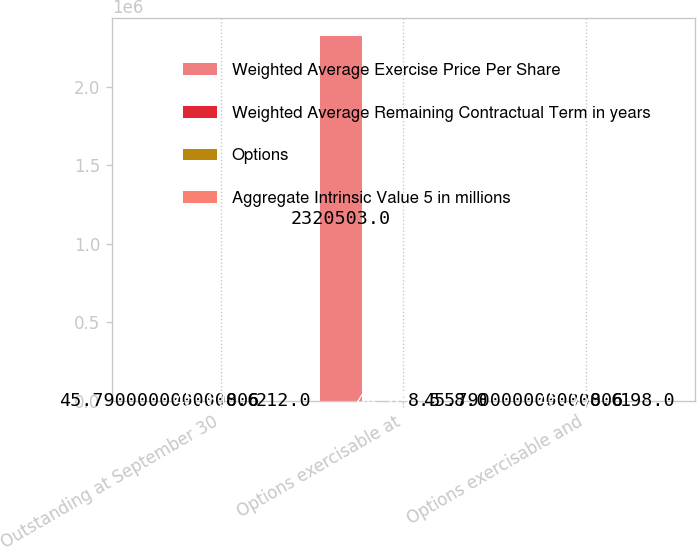Convert chart to OTSL. <chart><loc_0><loc_0><loc_500><loc_500><stacked_bar_chart><ecel><fcel>Outstanding at September 30<fcel>Options exercisable at<fcel>Options exercisable and<nl><fcel>Weighted Average Exercise Price Per Share<fcel>45.79<fcel>2.3205e+06<fcel>45.79<nl><fcel>Weighted Average Remaining Contractual Term in years<fcel>45.81<fcel>44.09<fcel>45.77<nl><fcel>Options<fcel>8.6<fcel>8.5<fcel>8.6<nl><fcel>Aggregate Intrinsic Value 5 in millions<fcel>212<fcel>58<fcel>198<nl></chart> 